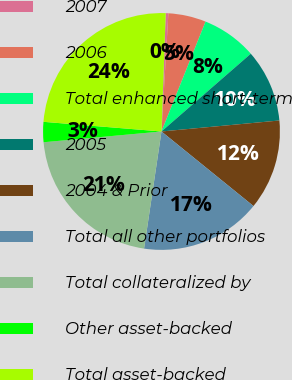<chart> <loc_0><loc_0><loc_500><loc_500><pie_chart><fcel>2007<fcel>2006<fcel>Total enhanced short-term<fcel>2005<fcel>2004 & Prior<fcel>Total all other portfolios<fcel>Total collateralized by<fcel>Other asset-backed<fcel>Total asset-backed<nl><fcel>0.36%<fcel>5.14%<fcel>7.53%<fcel>9.92%<fcel>12.32%<fcel>16.51%<fcel>21.2%<fcel>2.75%<fcel>24.27%<nl></chart> 